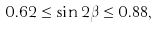<formula> <loc_0><loc_0><loc_500><loc_500>0 . 6 2 \leq \sin 2 \beta \leq 0 . 8 8 ,</formula> 